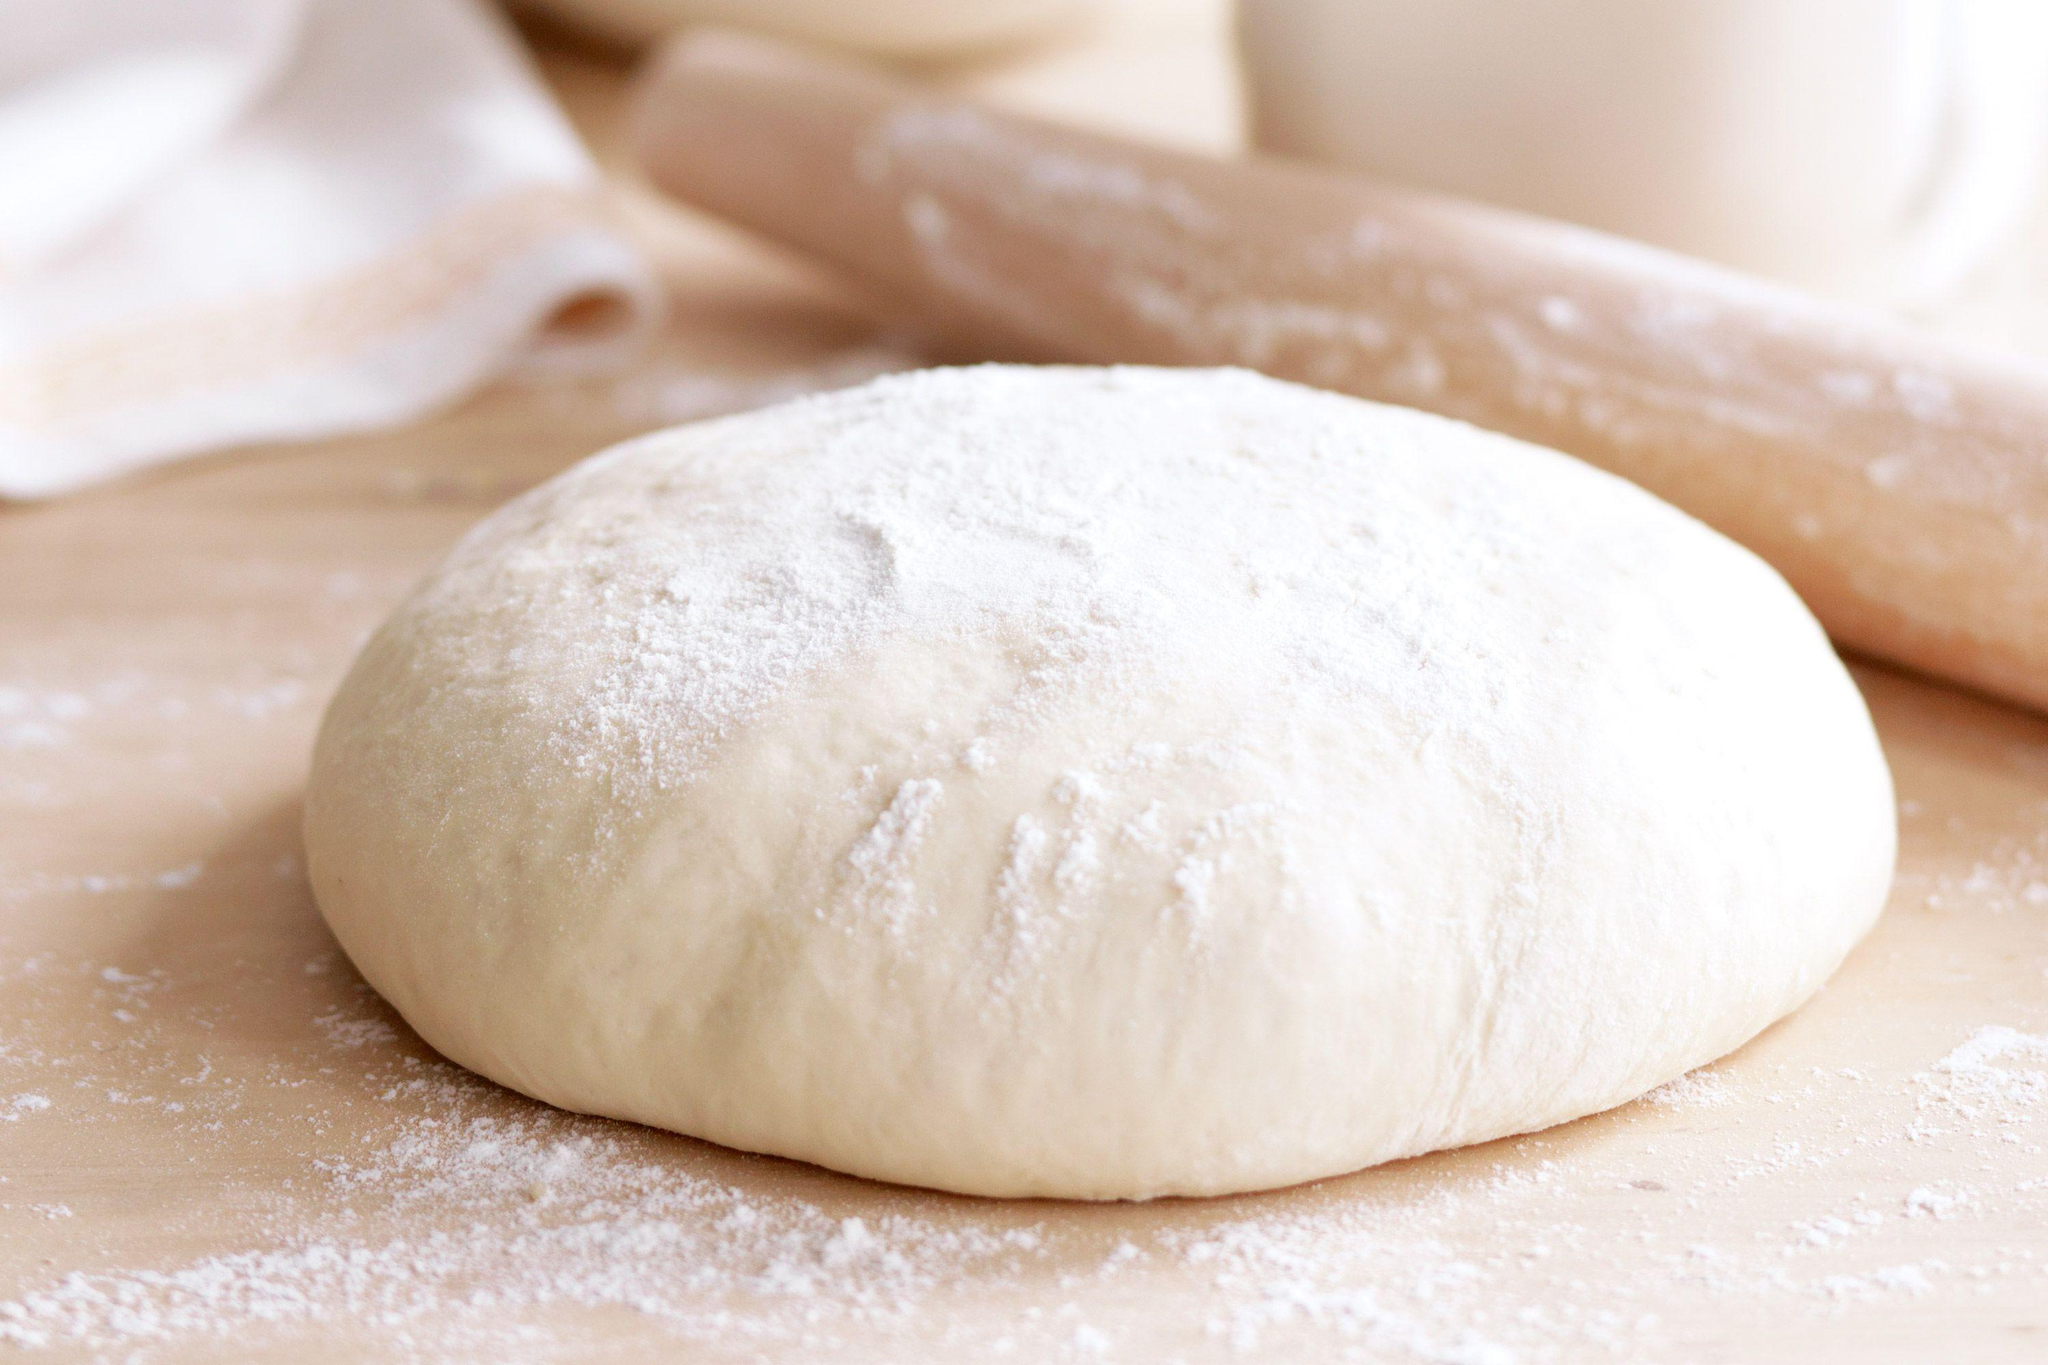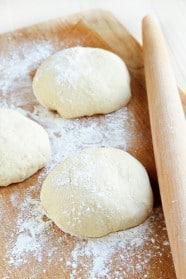The first image is the image on the left, the second image is the image on the right. Assess this claim about the two images: "One piece of dough is flattened.". Correct or not? Answer yes or no. No. 